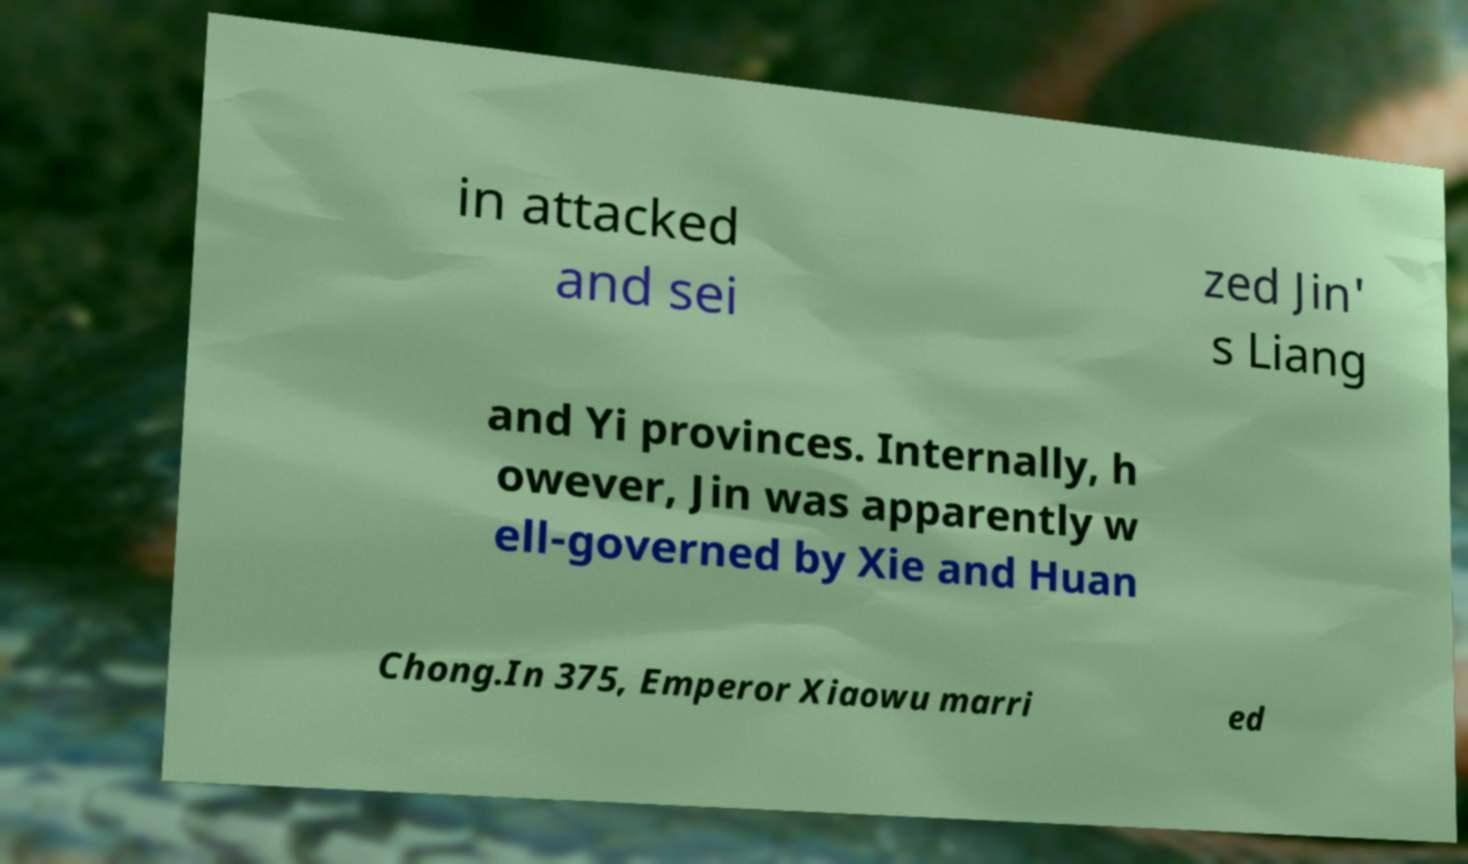Can you read and provide the text displayed in the image?This photo seems to have some interesting text. Can you extract and type it out for me? in attacked and sei zed Jin' s Liang and Yi provinces. Internally, h owever, Jin was apparently w ell-governed by Xie and Huan Chong.In 375, Emperor Xiaowu marri ed 